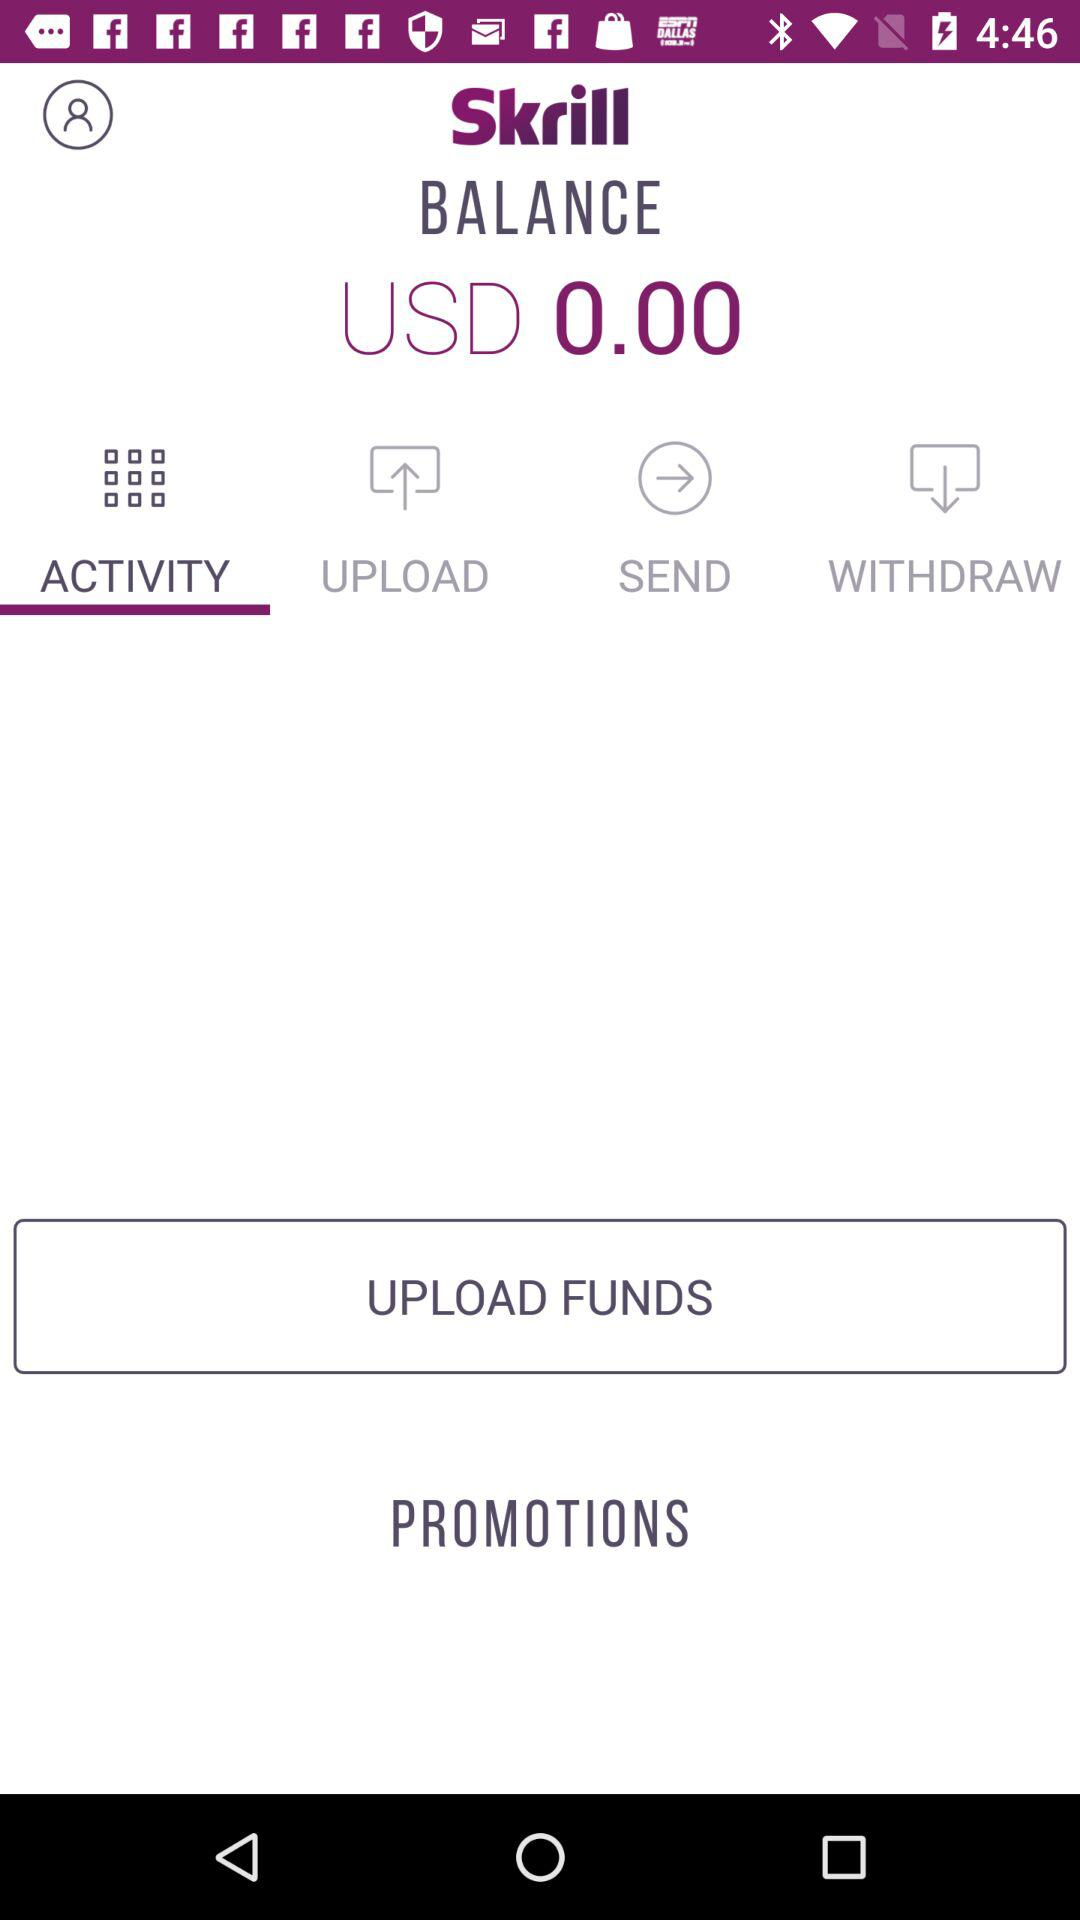What is the balance in USD? The balance is 0.00 USD. 